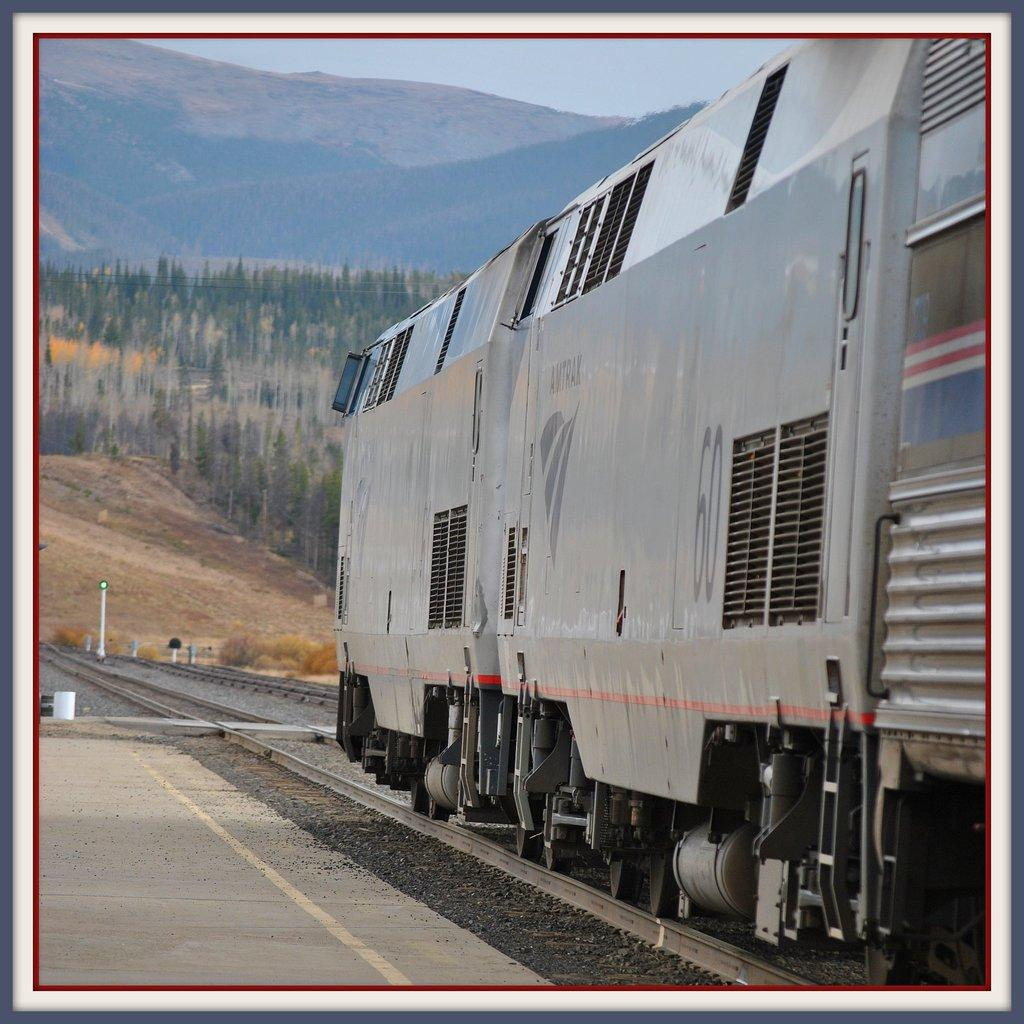What is located on the right side of the image? There is a train on the right side of the image. What can be seen in the background of the image? There are trees in the background of the image. What is the train positioned on in the image? The railway track is visible in the image. What is visible at the top of the image? The sky is visible at the top of the image. What type of table can be seen in the image? There is no table present in the image. Can you hear the sound of the sand in the image? There is no sand present in the image, so it is not possible to hear its sound. 